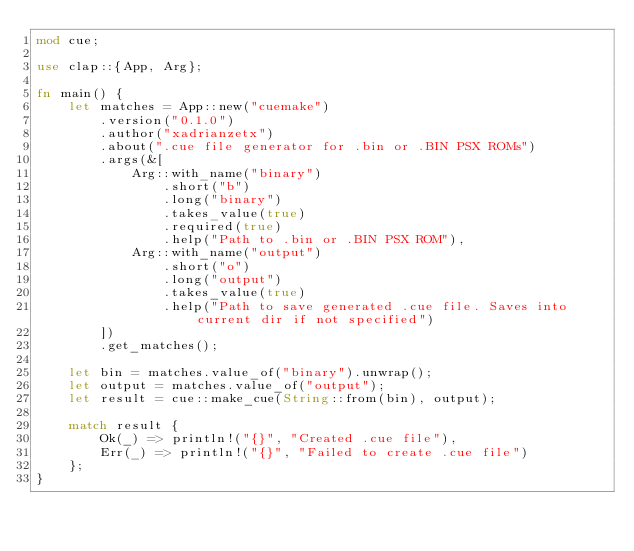Convert code to text. <code><loc_0><loc_0><loc_500><loc_500><_Rust_>mod cue;

use clap::{App, Arg};

fn main() {
    let matches = App::new("cuemake")
        .version("0.1.0")
        .author("xadrianzetx")
        .about(".cue file generator for .bin or .BIN PSX ROMs")
        .args(&[
            Arg::with_name("binary")
                .short("b")
                .long("binary")
                .takes_value(true)
                .required(true)
                .help("Path to .bin or .BIN PSX ROM"),
            Arg::with_name("output")
                .short("o")
                .long("output")
                .takes_value(true)
                .help("Path to save generated .cue file. Saves into current dir if not specified")
        ])
        .get_matches();
    
    let bin = matches.value_of("binary").unwrap();
    let output = matches.value_of("output");
    let result = cue::make_cue(String::from(bin), output);

    match result {
        Ok(_) => println!("{}", "Created .cue file"),
        Err(_) => println!("{}", "Failed to create .cue file")
    };
}
</code> 